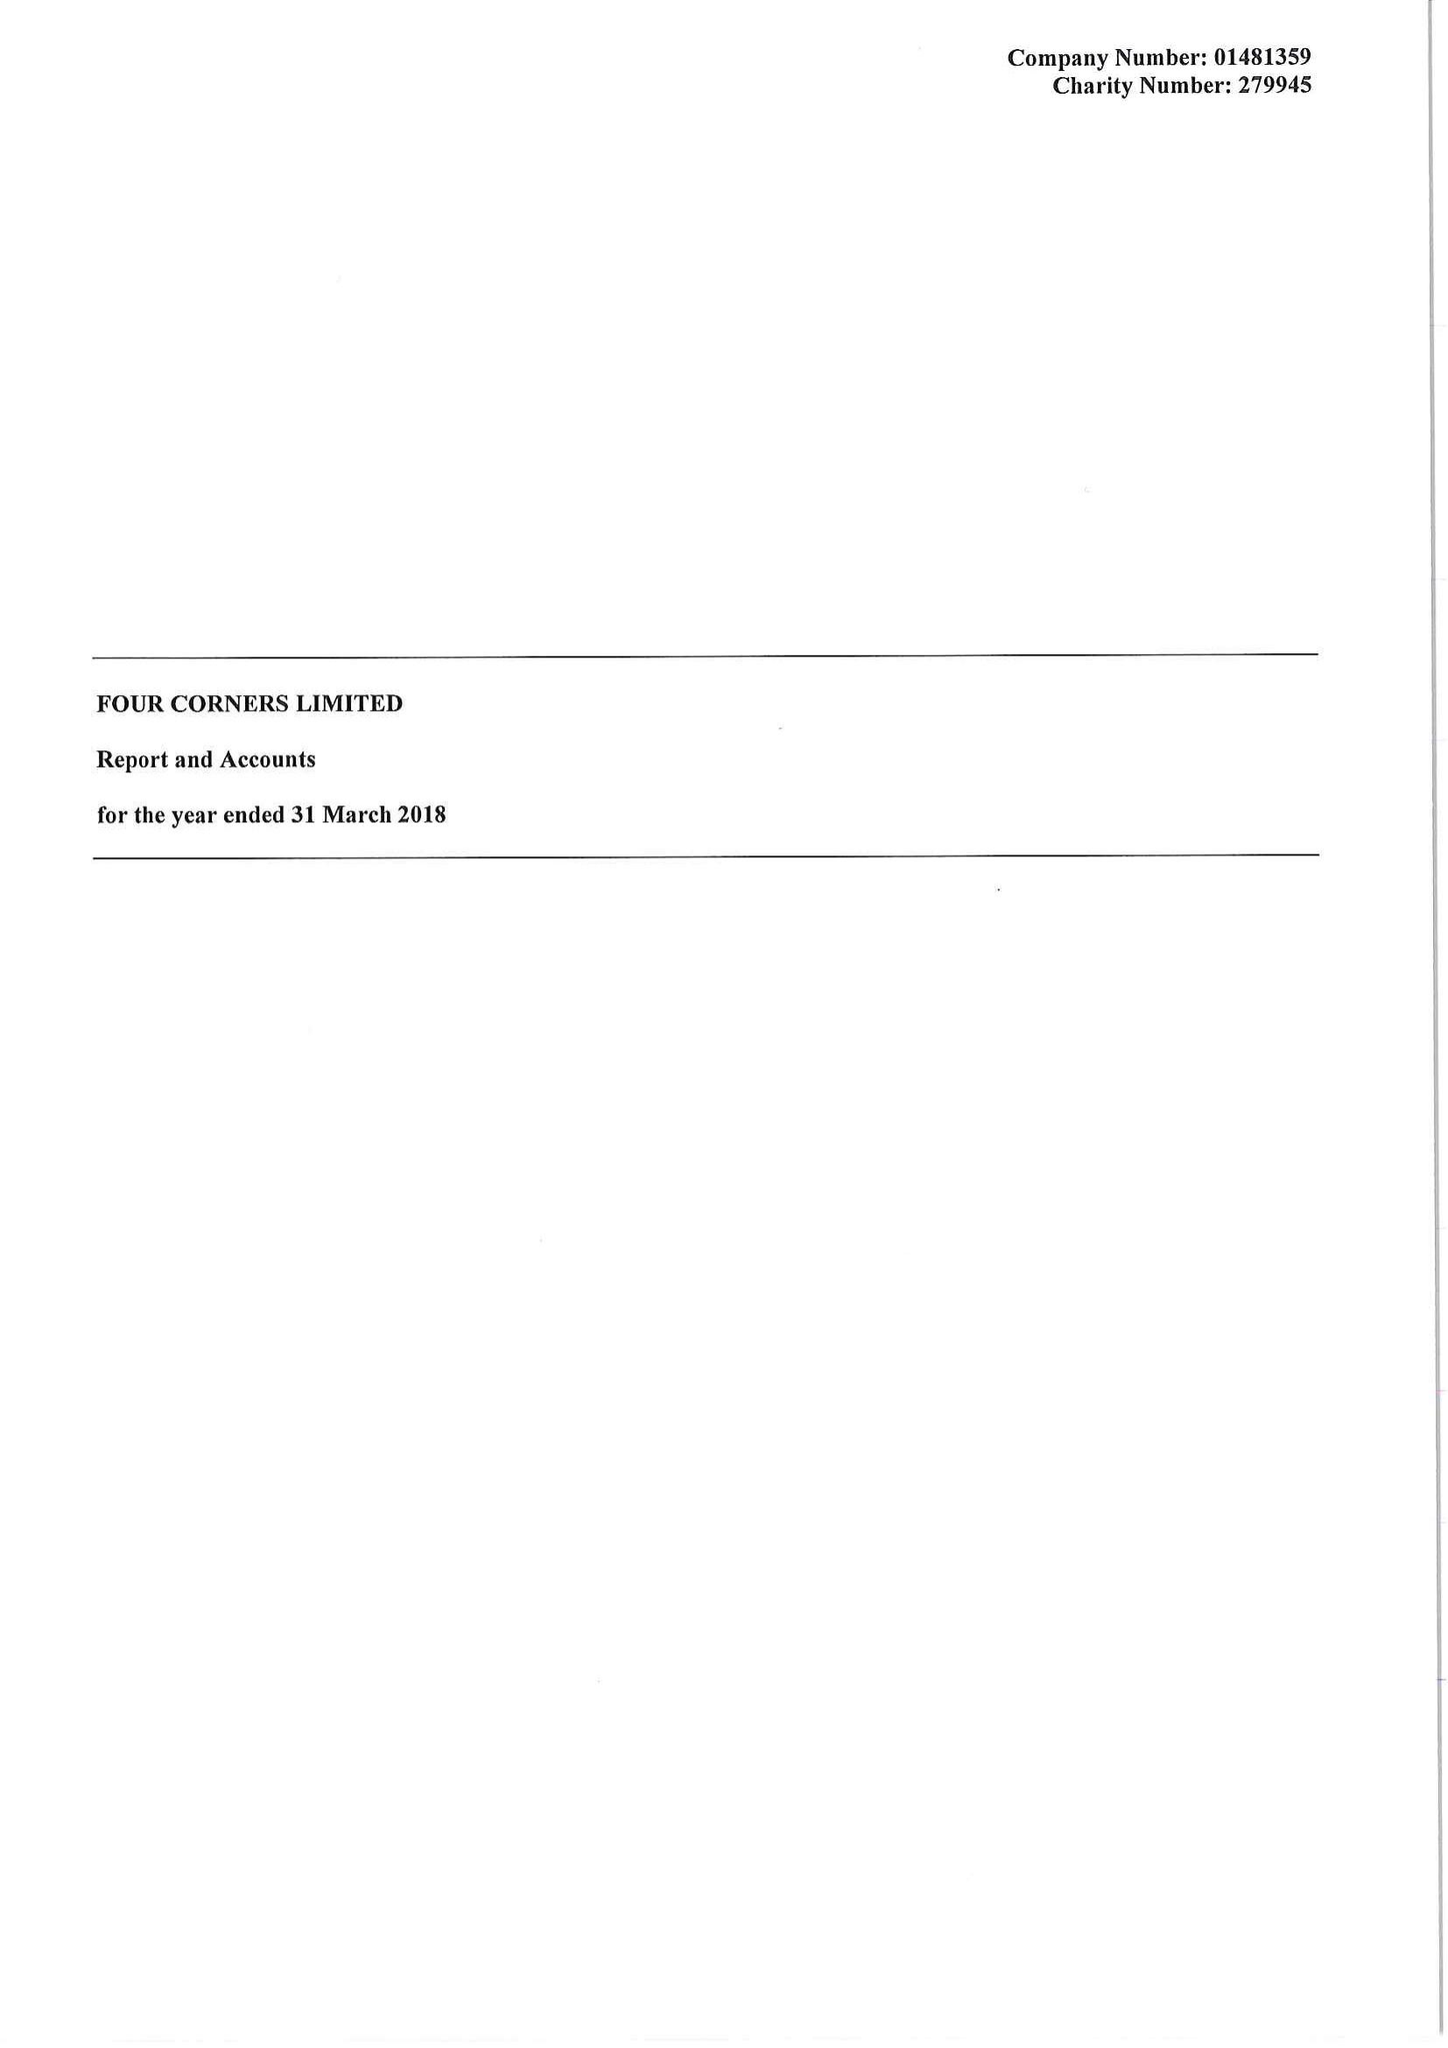What is the value for the address__street_line?
Answer the question using a single word or phrase. 121 ROMAN ROAD 